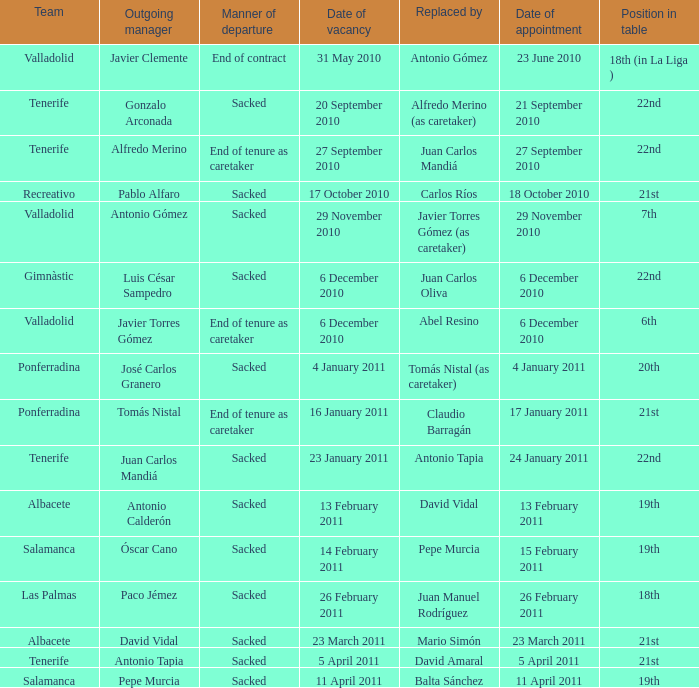How many teams had a departing manager of antonio gómez? 1.0. 